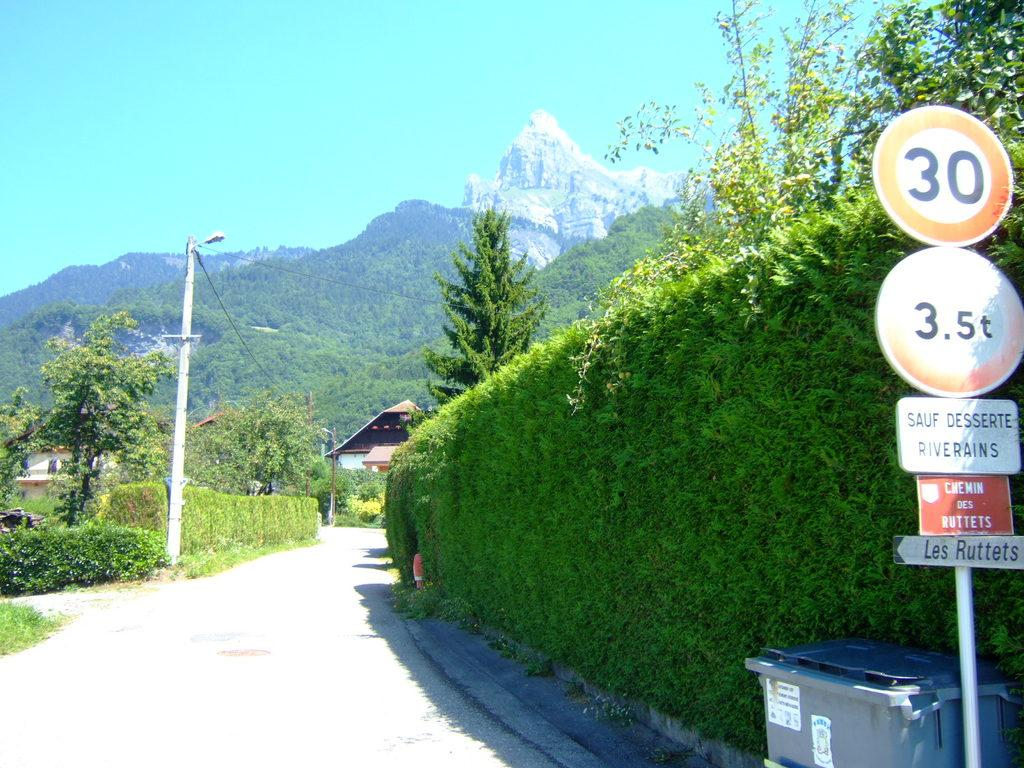Provide a one-sentence caption for the provided image. A small French road near the mountains has a speed limit of 30. 